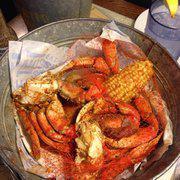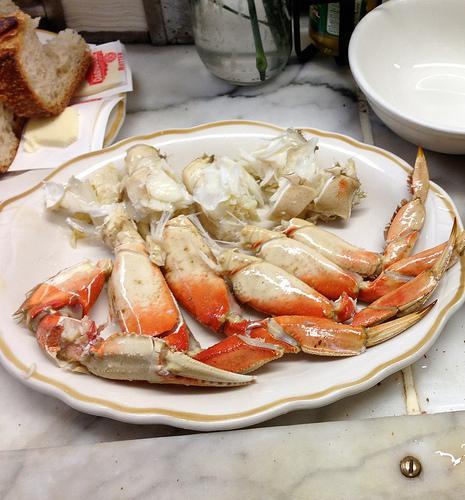The first image is the image on the left, the second image is the image on the right. Given the left and right images, does the statement "One of the images has cooked crab pieces on foil." hold true? Answer yes or no. Yes. The first image is the image on the left, the second image is the image on the right. For the images shown, is this caption "Left and right images each show crab claws in some type of container used in a kitchen." true? Answer yes or no. Yes. 